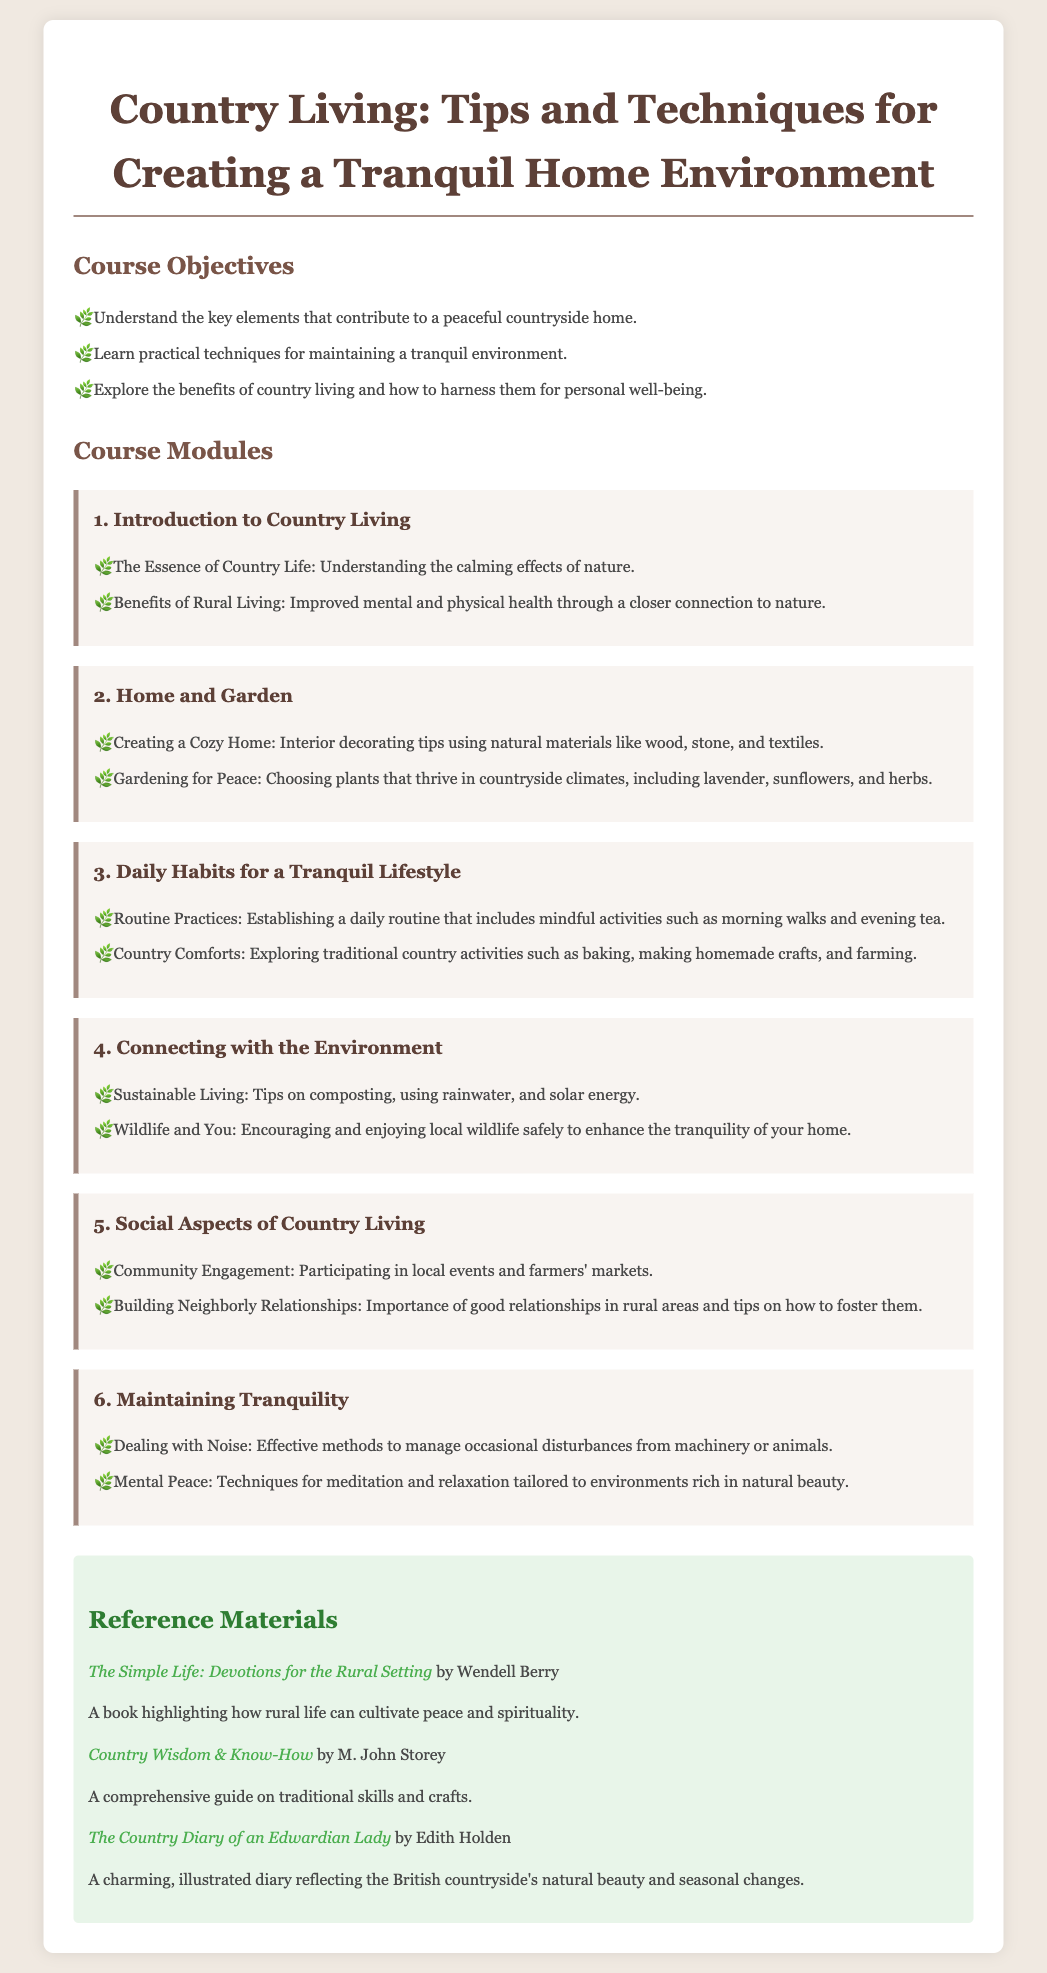What are the course objectives? The course objectives include understanding the key elements of a peaceful countryside home, learning practical techniques for maintaining a tranquil environment, and exploring the benefits of country living for personal well-being.
Answer: Understand the key elements that contribute to a peaceful countryside home; Learn practical techniques for maintaining a tranquil environment; Explore the benefits of country living and how to harness them for personal well-being What is the first module of the course? The first module of the course is titled "Introduction to Country Living."
Answer: Introduction to Country Living Name one plant mentioned for gardening in the country. The syllabus states several plants that thrive in countryside climates, one of which is lavender.
Answer: Lavender What is a daily habit suggested for a tranquil lifestyle? The document suggests establishing a daily routine that includes mindful activities such as morning walks and evening tea.
Answer: Morning walks What is one tip for maintaining tranquility? Tips provided in the document for maintaining tranquility include effective methods to manage occasional disturbances from machinery or animals.
Answer: Effective methods to manage disturbances How many reference materials are listed in the document? The document lists three reference materials related to country living.
Answer: Three What are the social aspects covered in the course? The social aspects include community engagement and building neighborly relationships.
Answer: Community engagement; Building neighborly relationships What does the course module on Environmental Connection focus on? This module emphasizes sustainable living, including tips on composting and using rainwater.
Answer: Sustainable Living: Tips on composting, using rainwater, and solar energy 